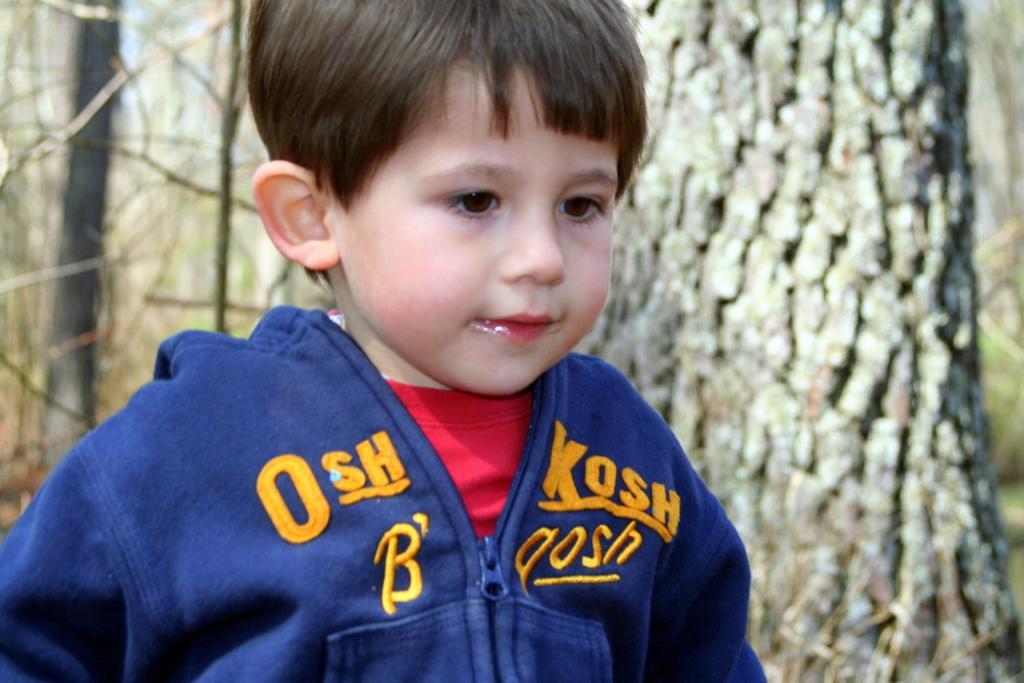Could you give a brief overview of what you see in this image? In this picture I can see a boy, behind we can see some tree trunks. 